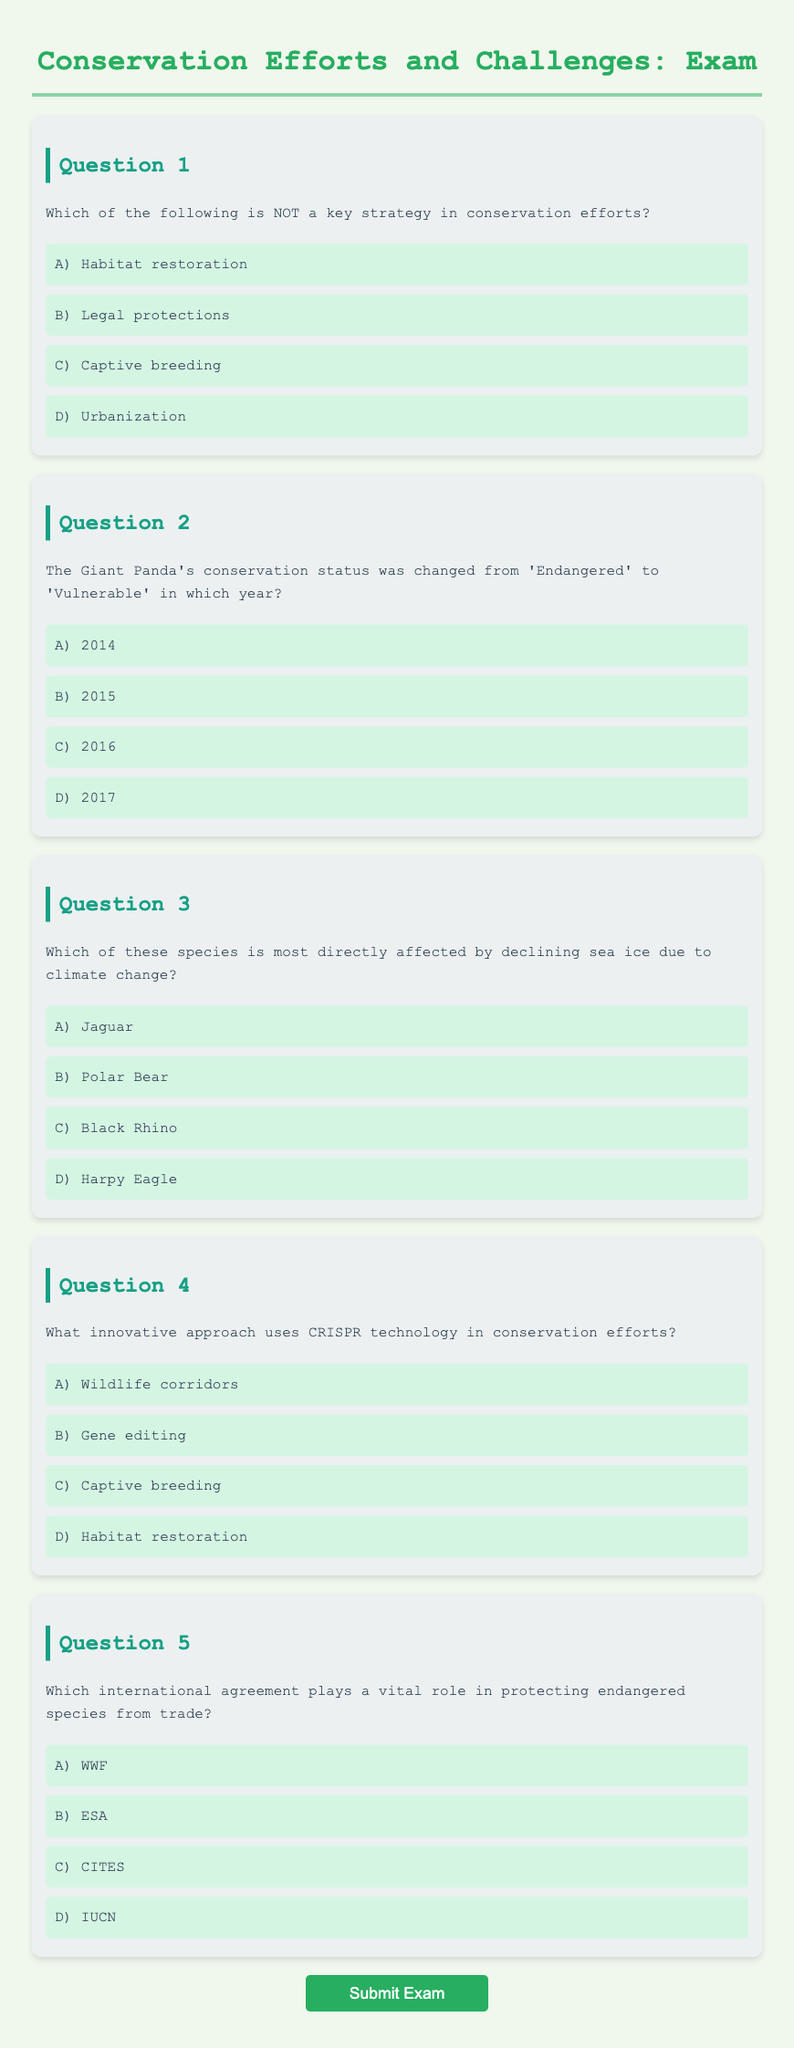What is the title of the document? The title of the document is indicated as the main heading: "Conservation Efforts and Challenges: Exam."
Answer: Conservation Efforts and Challenges: Exam How many questions are included in the exam? The document contains a total of five questions, as observed from the listed question blocks.
Answer: 5 Which strategy is NOT listed as a key strategy in conservation efforts? From the options in Question 1, "Urbanization" is highlighted as the non-strategy for conservation efforts.
Answer: Urbanization In what year did the Giant Panda's status change to 'Vulnerable'? According to Question 2, the Giant Panda's conservation status was changed in 2016.
Answer: 2016 Which species is negatively impacted by declining sea ice? The response to Question 3 identifies "Polar Bear" as the species most directly affected by this environmental change.
Answer: Polar Bear What is the innovative approach using CRISPR in conservation efforts? Question 4 specifies that the innovative approach referenced is "Gene editing."
Answer: Gene editing Which international agreement protects endangered species from trade? The correct answer as per Question 5 is "CITES," which is vital for protecting endangered species.
Answer: CITES What type of technology is mentioned in relation to conservation in the document? The mention of "CRISPR technology" in Question 4 indicates the type of technology referred to in conservation efforts.
Answer: CRISPR technology Who is encouraged to think beyond animated films in conservation? The message in the JavaScript alert highlights that individuals are encouraged to think beyond simple depictions, including those in animated films.
Answer: Individuals 